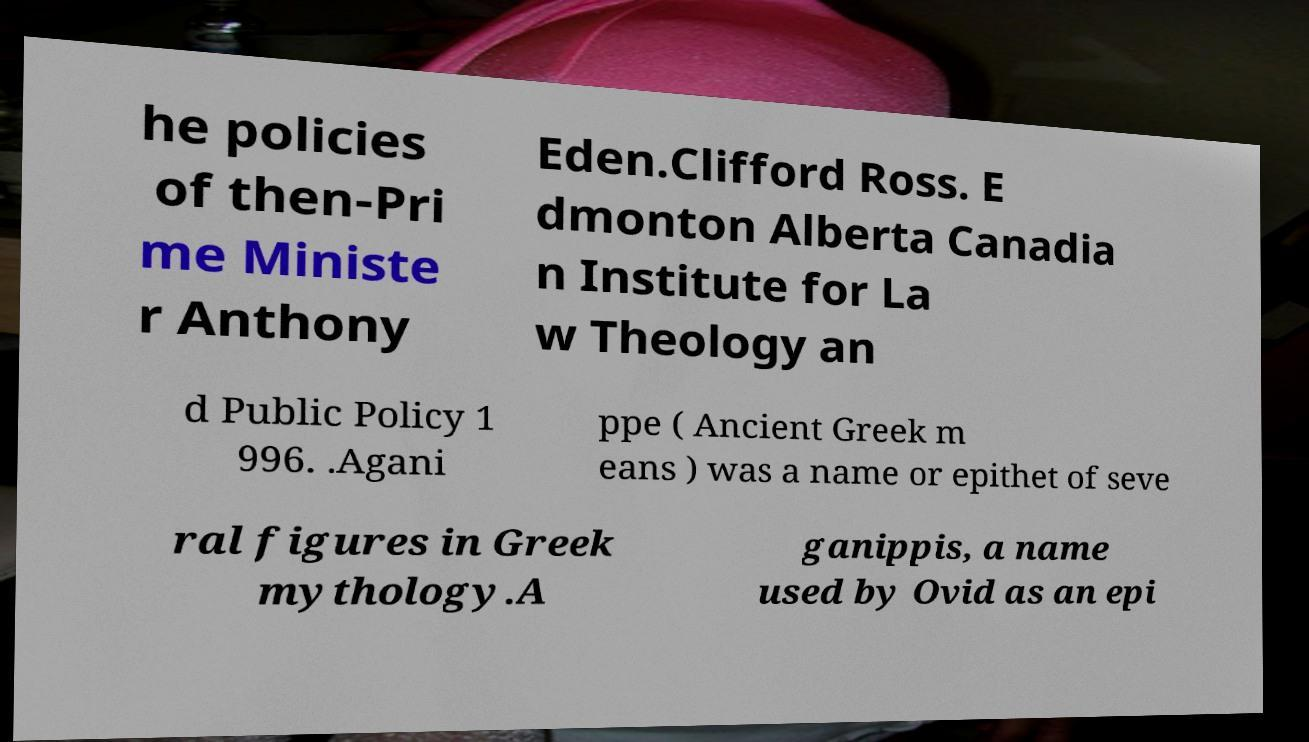Can you read and provide the text displayed in the image?This photo seems to have some interesting text. Can you extract and type it out for me? he policies of then-Pri me Ministe r Anthony Eden.Clifford Ross. E dmonton Alberta Canadia n Institute for La w Theology an d Public Policy 1 996. .Agani ppe ( Ancient Greek m eans ) was a name or epithet of seve ral figures in Greek mythology.A ganippis, a name used by Ovid as an epi 